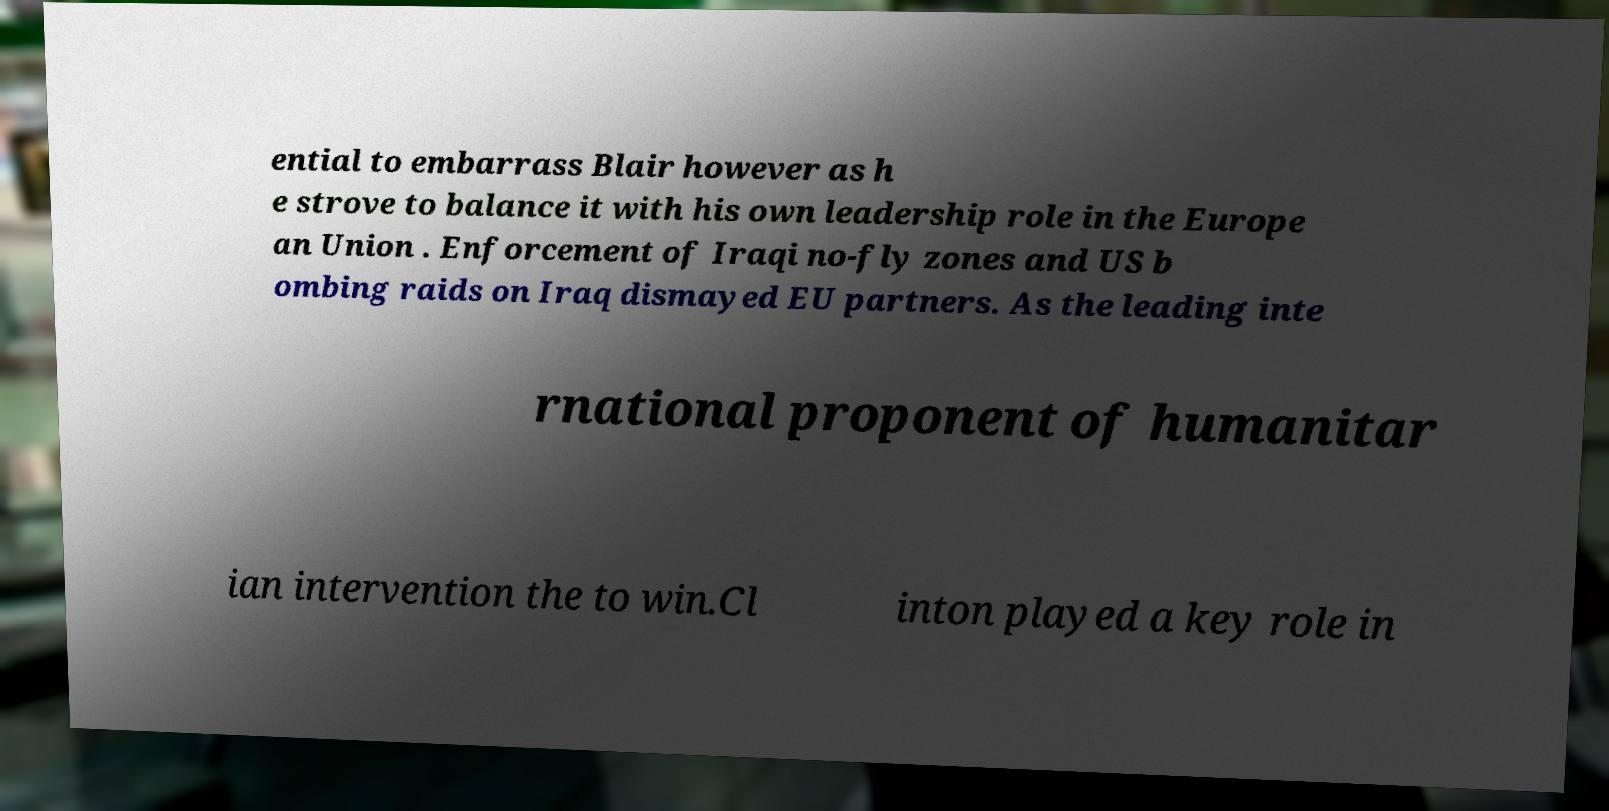For documentation purposes, I need the text within this image transcribed. Could you provide that? ential to embarrass Blair however as h e strove to balance it with his own leadership role in the Europe an Union . Enforcement of Iraqi no-fly zones and US b ombing raids on Iraq dismayed EU partners. As the leading inte rnational proponent of humanitar ian intervention the to win.Cl inton played a key role in 